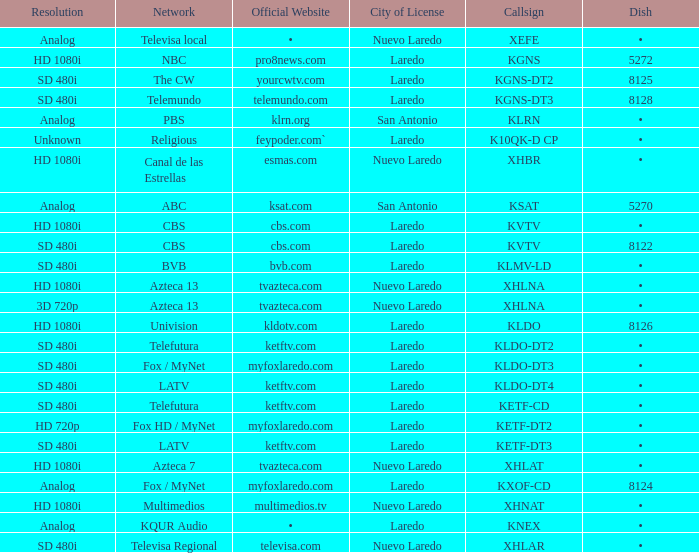Name the dish for resolution of sd 480i and network of bvb •. 